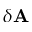Convert formula to latex. <formula><loc_0><loc_0><loc_500><loc_500>\delta { A }</formula> 